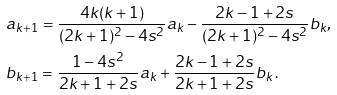Convert formula to latex. <formula><loc_0><loc_0><loc_500><loc_500>& a _ { k + 1 } = \frac { 4 k ( k + 1 ) } { ( 2 k + 1 ) ^ { 2 } - 4 s ^ { 2 } } a _ { k } - \frac { 2 k - 1 + 2 s } { ( 2 k + 1 ) ^ { 2 } - 4 s ^ { 2 } } b _ { k } , \\ & b _ { k + 1 } = \frac { 1 - 4 s ^ { 2 } } { 2 k + 1 + 2 s } a _ { k } + \frac { 2 k - 1 + 2 s } { 2 k + 1 + 2 s } b _ { k } \, .</formula> 